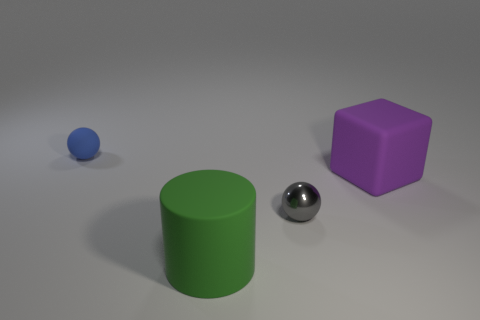There is a tiny sphere in front of the tiny thing left of the gray metal sphere; what is its color?
Keep it short and to the point. Gray. Are there any purple rubber cubes of the same size as the green rubber cylinder?
Your answer should be compact. Yes. What is the object that is behind the matte thing to the right of the large rubber thing in front of the purple matte cube made of?
Offer a very short reply. Rubber. There is a big matte thing that is in front of the big block; what number of metal objects are in front of it?
Give a very brief answer. 0. Is the size of the ball that is in front of the blue ball the same as the block?
Make the answer very short. No. How many blue things are the same shape as the purple object?
Provide a succinct answer. 0. What is the shape of the blue object?
Your response must be concise. Sphere. Are there an equal number of large green matte cylinders behind the purple object and big green matte cubes?
Provide a succinct answer. Yes. Is there any other thing that has the same material as the tiny gray sphere?
Offer a very short reply. No. Is the sphere on the right side of the green rubber thing made of the same material as the big green cylinder?
Offer a terse response. No. 